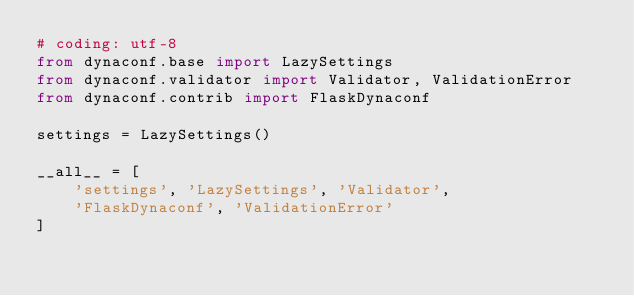<code> <loc_0><loc_0><loc_500><loc_500><_Python_># coding: utf-8
from dynaconf.base import LazySettings
from dynaconf.validator import Validator, ValidationError
from dynaconf.contrib import FlaskDynaconf

settings = LazySettings()

__all__ = [
    'settings', 'LazySettings', 'Validator',
    'FlaskDynaconf', 'ValidationError'
]
</code> 